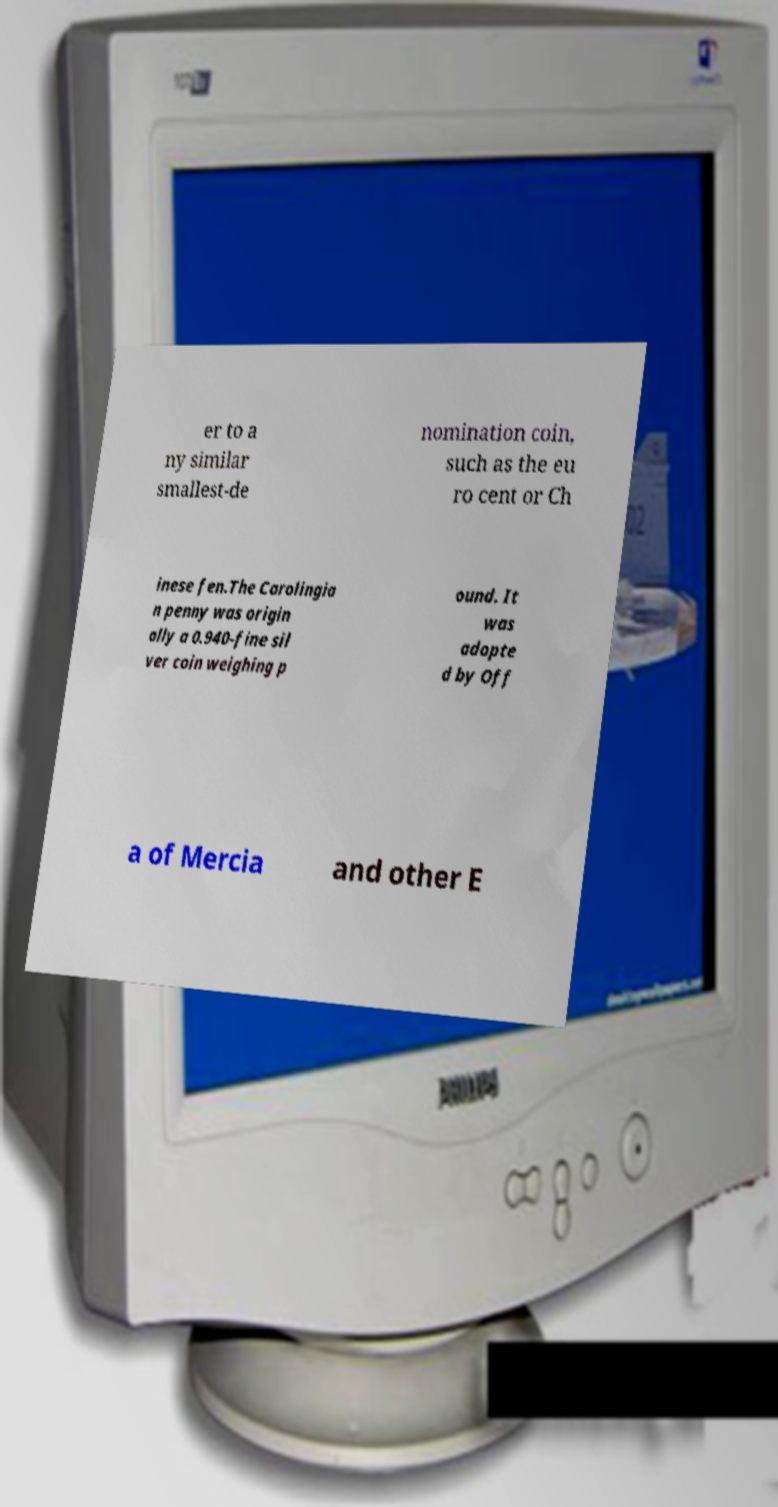There's text embedded in this image that I need extracted. Can you transcribe it verbatim? er to a ny similar smallest-de nomination coin, such as the eu ro cent or Ch inese fen.The Carolingia n penny was origin ally a 0.940-fine sil ver coin weighing p ound. It was adopte d by Off a of Mercia and other E 